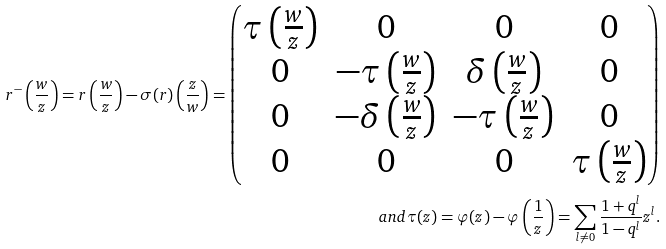Convert formula to latex. <formula><loc_0><loc_0><loc_500><loc_500>r ^ { - } \left ( \frac { w } { z } \right ) = r \left ( \frac { w } { z } \right ) - \sigma ( r ) \left ( \frac { z } { w } \right ) = \left ( \begin{matrix} \tau \left ( \frac { w } { z } \right ) & 0 & 0 & 0 \\ 0 & - \tau \left ( \frac { w } { z } \right ) & \delta \left ( \frac { w } { z } \right ) & 0 \\ 0 & - \delta \left ( \frac { w } { z } \right ) & - \tau \left ( \frac { w } { z } \right ) & 0 \\ 0 & 0 & 0 & \tau \left ( \frac { w } { z } \right ) \end{matrix} \right ) \\ a n d \tau ( z ) = \varphi ( z ) - \varphi \left ( \frac { 1 } { z } \right ) = \sum _ { l \neq 0 } \frac { 1 + q ^ { l } } { 1 - q ^ { l } } z ^ { l } .</formula> 